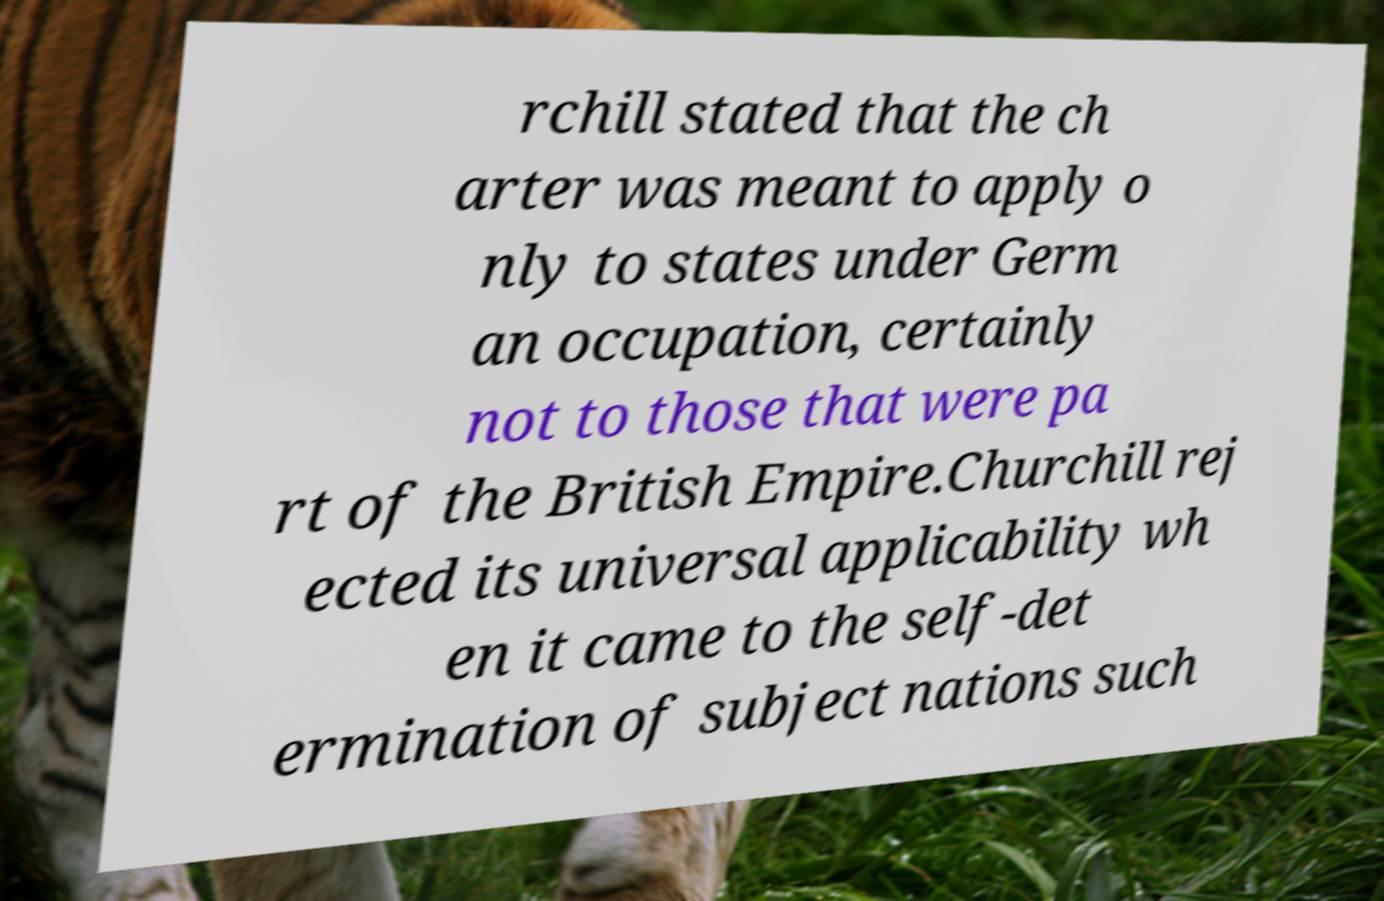Could you assist in decoding the text presented in this image and type it out clearly? rchill stated that the ch arter was meant to apply o nly to states under Germ an occupation, certainly not to those that were pa rt of the British Empire.Churchill rej ected its universal applicability wh en it came to the self-det ermination of subject nations such 